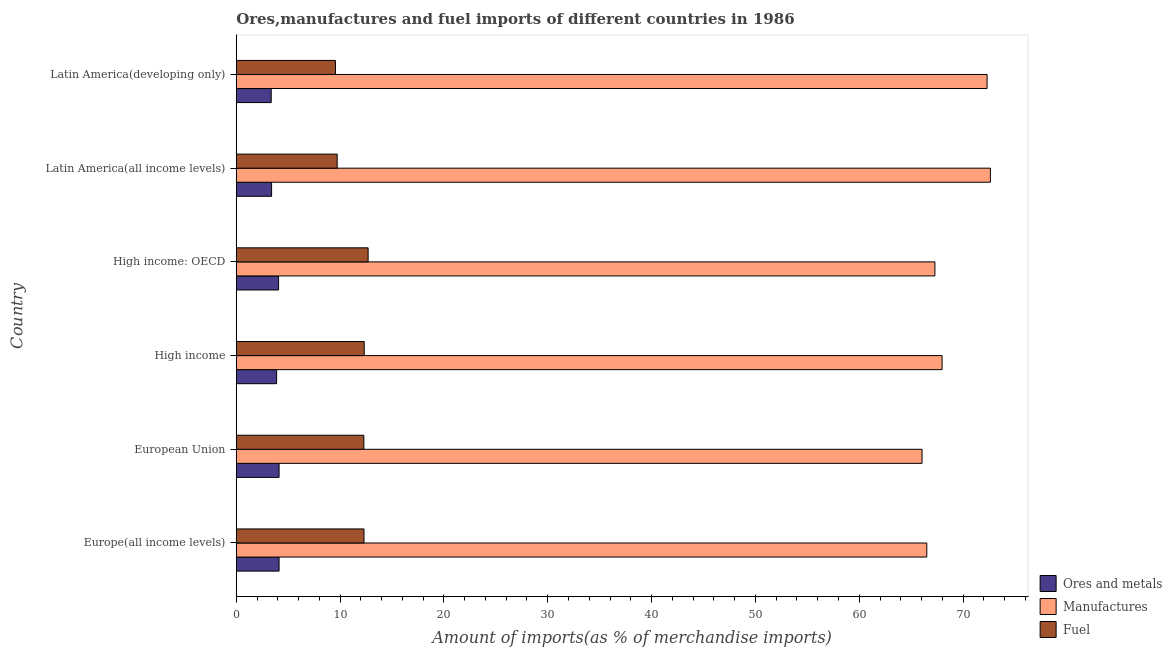How many different coloured bars are there?
Keep it short and to the point. 3. Are the number of bars per tick equal to the number of legend labels?
Ensure brevity in your answer.  Yes. How many bars are there on the 5th tick from the top?
Provide a short and direct response. 3. How many bars are there on the 1st tick from the bottom?
Provide a short and direct response. 3. What is the label of the 1st group of bars from the top?
Make the answer very short. Latin America(developing only). In how many cases, is the number of bars for a given country not equal to the number of legend labels?
Ensure brevity in your answer.  0. What is the percentage of fuel imports in Latin America(all income levels)?
Your answer should be very brief. 9.72. Across all countries, what is the maximum percentage of manufactures imports?
Ensure brevity in your answer.  72.63. Across all countries, what is the minimum percentage of ores and metals imports?
Offer a terse response. 3.37. In which country was the percentage of fuel imports maximum?
Provide a succinct answer. High income: OECD. In which country was the percentage of ores and metals imports minimum?
Provide a short and direct response. Latin America(developing only). What is the total percentage of ores and metals imports in the graph?
Offer a terse response. 22.98. What is the difference between the percentage of ores and metals imports in European Union and that in Latin America(all income levels)?
Ensure brevity in your answer.  0.72. What is the difference between the percentage of ores and metals imports in Europe(all income levels) and the percentage of manufactures imports in European Union?
Offer a terse response. -61.92. What is the average percentage of fuel imports per country?
Give a very brief answer. 11.48. What is the difference between the percentage of fuel imports and percentage of ores and metals imports in High income: OECD?
Keep it short and to the point. 8.62. In how many countries, is the percentage of ores and metals imports greater than 16 %?
Provide a short and direct response. 0. What is the ratio of the percentage of ores and metals imports in High income to that in Latin America(developing only)?
Offer a terse response. 1.16. What is the difference between the highest and the second highest percentage of manufactures imports?
Ensure brevity in your answer.  0.32. What is the difference between the highest and the lowest percentage of ores and metals imports?
Your answer should be very brief. 0.76. In how many countries, is the percentage of fuel imports greater than the average percentage of fuel imports taken over all countries?
Your answer should be very brief. 4. Is the sum of the percentage of ores and metals imports in High income: OECD and Latin America(developing only) greater than the maximum percentage of manufactures imports across all countries?
Your response must be concise. No. What does the 2nd bar from the top in High income: OECD represents?
Provide a succinct answer. Manufactures. What does the 2nd bar from the bottom in High income represents?
Offer a terse response. Manufactures. Are all the bars in the graph horizontal?
Make the answer very short. Yes. How many countries are there in the graph?
Your answer should be compact. 6. What is the difference between two consecutive major ticks on the X-axis?
Keep it short and to the point. 10. Does the graph contain any zero values?
Provide a succinct answer. No. How many legend labels are there?
Your answer should be very brief. 3. What is the title of the graph?
Offer a very short reply. Ores,manufactures and fuel imports of different countries in 1986. Does "Spain" appear as one of the legend labels in the graph?
Your answer should be compact. No. What is the label or title of the X-axis?
Offer a terse response. Amount of imports(as % of merchandise imports). What is the Amount of imports(as % of merchandise imports) in Ores and metals in Europe(all income levels)?
Offer a terse response. 4.12. What is the Amount of imports(as % of merchandise imports) in Manufactures in Europe(all income levels)?
Your response must be concise. 66.51. What is the Amount of imports(as % of merchandise imports) of Fuel in Europe(all income levels)?
Keep it short and to the point. 12.3. What is the Amount of imports(as % of merchandise imports) of Ores and metals in European Union?
Offer a very short reply. 4.12. What is the Amount of imports(as % of merchandise imports) in Manufactures in European Union?
Ensure brevity in your answer.  66.05. What is the Amount of imports(as % of merchandise imports) of Fuel in European Union?
Provide a succinct answer. 12.29. What is the Amount of imports(as % of merchandise imports) in Ores and metals in High income?
Offer a very short reply. 3.89. What is the Amount of imports(as % of merchandise imports) in Manufactures in High income?
Give a very brief answer. 67.98. What is the Amount of imports(as % of merchandise imports) in Fuel in High income?
Keep it short and to the point. 12.32. What is the Amount of imports(as % of merchandise imports) in Ores and metals in High income: OECD?
Give a very brief answer. 4.08. What is the Amount of imports(as % of merchandise imports) in Manufactures in High income: OECD?
Provide a short and direct response. 67.29. What is the Amount of imports(as % of merchandise imports) of Fuel in High income: OECD?
Your answer should be compact. 12.7. What is the Amount of imports(as % of merchandise imports) of Ores and metals in Latin America(all income levels)?
Your response must be concise. 3.4. What is the Amount of imports(as % of merchandise imports) in Manufactures in Latin America(all income levels)?
Keep it short and to the point. 72.63. What is the Amount of imports(as % of merchandise imports) in Fuel in Latin America(all income levels)?
Your answer should be compact. 9.72. What is the Amount of imports(as % of merchandise imports) in Ores and metals in Latin America(developing only)?
Offer a very short reply. 3.37. What is the Amount of imports(as % of merchandise imports) of Manufactures in Latin America(developing only)?
Offer a terse response. 72.31. What is the Amount of imports(as % of merchandise imports) in Fuel in Latin America(developing only)?
Keep it short and to the point. 9.55. Across all countries, what is the maximum Amount of imports(as % of merchandise imports) in Ores and metals?
Your response must be concise. 4.12. Across all countries, what is the maximum Amount of imports(as % of merchandise imports) in Manufactures?
Ensure brevity in your answer.  72.63. Across all countries, what is the maximum Amount of imports(as % of merchandise imports) in Fuel?
Your answer should be very brief. 12.7. Across all countries, what is the minimum Amount of imports(as % of merchandise imports) of Ores and metals?
Your answer should be very brief. 3.37. Across all countries, what is the minimum Amount of imports(as % of merchandise imports) of Manufactures?
Offer a very short reply. 66.05. Across all countries, what is the minimum Amount of imports(as % of merchandise imports) of Fuel?
Keep it short and to the point. 9.55. What is the total Amount of imports(as % of merchandise imports) in Ores and metals in the graph?
Give a very brief answer. 22.98. What is the total Amount of imports(as % of merchandise imports) of Manufactures in the graph?
Offer a terse response. 412.77. What is the total Amount of imports(as % of merchandise imports) of Fuel in the graph?
Your answer should be very brief. 68.89. What is the difference between the Amount of imports(as % of merchandise imports) in Manufactures in Europe(all income levels) and that in European Union?
Offer a very short reply. 0.46. What is the difference between the Amount of imports(as % of merchandise imports) in Fuel in Europe(all income levels) and that in European Union?
Make the answer very short. 0.01. What is the difference between the Amount of imports(as % of merchandise imports) of Ores and metals in Europe(all income levels) and that in High income?
Offer a very short reply. 0.24. What is the difference between the Amount of imports(as % of merchandise imports) in Manufactures in Europe(all income levels) and that in High income?
Keep it short and to the point. -1.47. What is the difference between the Amount of imports(as % of merchandise imports) in Fuel in Europe(all income levels) and that in High income?
Offer a very short reply. -0.02. What is the difference between the Amount of imports(as % of merchandise imports) in Ores and metals in Europe(all income levels) and that in High income: OECD?
Your response must be concise. 0.05. What is the difference between the Amount of imports(as % of merchandise imports) of Manufactures in Europe(all income levels) and that in High income: OECD?
Keep it short and to the point. -0.78. What is the difference between the Amount of imports(as % of merchandise imports) of Fuel in Europe(all income levels) and that in High income: OECD?
Provide a succinct answer. -0.4. What is the difference between the Amount of imports(as % of merchandise imports) of Ores and metals in Europe(all income levels) and that in Latin America(all income levels)?
Offer a very short reply. 0.72. What is the difference between the Amount of imports(as % of merchandise imports) in Manufactures in Europe(all income levels) and that in Latin America(all income levels)?
Your response must be concise. -6.13. What is the difference between the Amount of imports(as % of merchandise imports) of Fuel in Europe(all income levels) and that in Latin America(all income levels)?
Your answer should be very brief. 2.59. What is the difference between the Amount of imports(as % of merchandise imports) of Ores and metals in Europe(all income levels) and that in Latin America(developing only)?
Offer a very short reply. 0.76. What is the difference between the Amount of imports(as % of merchandise imports) of Manufactures in Europe(all income levels) and that in Latin America(developing only)?
Offer a very short reply. -5.81. What is the difference between the Amount of imports(as % of merchandise imports) in Fuel in Europe(all income levels) and that in Latin America(developing only)?
Your response must be concise. 2.75. What is the difference between the Amount of imports(as % of merchandise imports) in Ores and metals in European Union and that in High income?
Your response must be concise. 0.24. What is the difference between the Amount of imports(as % of merchandise imports) in Manufactures in European Union and that in High income?
Provide a short and direct response. -1.93. What is the difference between the Amount of imports(as % of merchandise imports) of Fuel in European Union and that in High income?
Your answer should be compact. -0.03. What is the difference between the Amount of imports(as % of merchandise imports) in Ores and metals in European Union and that in High income: OECD?
Give a very brief answer. 0.05. What is the difference between the Amount of imports(as % of merchandise imports) in Manufactures in European Union and that in High income: OECD?
Make the answer very short. -1.24. What is the difference between the Amount of imports(as % of merchandise imports) of Fuel in European Union and that in High income: OECD?
Offer a terse response. -0.41. What is the difference between the Amount of imports(as % of merchandise imports) in Ores and metals in European Union and that in Latin America(all income levels)?
Offer a very short reply. 0.72. What is the difference between the Amount of imports(as % of merchandise imports) in Manufactures in European Union and that in Latin America(all income levels)?
Provide a succinct answer. -6.58. What is the difference between the Amount of imports(as % of merchandise imports) of Fuel in European Union and that in Latin America(all income levels)?
Make the answer very short. 2.57. What is the difference between the Amount of imports(as % of merchandise imports) of Ores and metals in European Union and that in Latin America(developing only)?
Your answer should be compact. 0.76. What is the difference between the Amount of imports(as % of merchandise imports) of Manufactures in European Union and that in Latin America(developing only)?
Offer a very short reply. -6.26. What is the difference between the Amount of imports(as % of merchandise imports) in Fuel in European Union and that in Latin America(developing only)?
Offer a terse response. 2.74. What is the difference between the Amount of imports(as % of merchandise imports) of Ores and metals in High income and that in High income: OECD?
Offer a terse response. -0.19. What is the difference between the Amount of imports(as % of merchandise imports) in Manufactures in High income and that in High income: OECD?
Make the answer very short. 0.69. What is the difference between the Amount of imports(as % of merchandise imports) in Fuel in High income and that in High income: OECD?
Your answer should be compact. -0.38. What is the difference between the Amount of imports(as % of merchandise imports) of Ores and metals in High income and that in Latin America(all income levels)?
Make the answer very short. 0.48. What is the difference between the Amount of imports(as % of merchandise imports) in Manufactures in High income and that in Latin America(all income levels)?
Provide a short and direct response. -4.65. What is the difference between the Amount of imports(as % of merchandise imports) of Fuel in High income and that in Latin America(all income levels)?
Give a very brief answer. 2.61. What is the difference between the Amount of imports(as % of merchandise imports) in Ores and metals in High income and that in Latin America(developing only)?
Your answer should be compact. 0.52. What is the difference between the Amount of imports(as % of merchandise imports) of Manufactures in High income and that in Latin America(developing only)?
Your answer should be compact. -4.33. What is the difference between the Amount of imports(as % of merchandise imports) of Fuel in High income and that in Latin America(developing only)?
Offer a terse response. 2.77. What is the difference between the Amount of imports(as % of merchandise imports) in Ores and metals in High income: OECD and that in Latin America(all income levels)?
Offer a terse response. 0.67. What is the difference between the Amount of imports(as % of merchandise imports) in Manufactures in High income: OECD and that in Latin America(all income levels)?
Provide a short and direct response. -5.34. What is the difference between the Amount of imports(as % of merchandise imports) of Fuel in High income: OECD and that in Latin America(all income levels)?
Your answer should be compact. 2.98. What is the difference between the Amount of imports(as % of merchandise imports) of Ores and metals in High income: OECD and that in Latin America(developing only)?
Make the answer very short. 0.71. What is the difference between the Amount of imports(as % of merchandise imports) in Manufactures in High income: OECD and that in Latin America(developing only)?
Your answer should be very brief. -5.02. What is the difference between the Amount of imports(as % of merchandise imports) of Fuel in High income: OECD and that in Latin America(developing only)?
Provide a short and direct response. 3.15. What is the difference between the Amount of imports(as % of merchandise imports) of Ores and metals in Latin America(all income levels) and that in Latin America(developing only)?
Ensure brevity in your answer.  0.04. What is the difference between the Amount of imports(as % of merchandise imports) in Manufactures in Latin America(all income levels) and that in Latin America(developing only)?
Your answer should be compact. 0.32. What is the difference between the Amount of imports(as % of merchandise imports) in Fuel in Latin America(all income levels) and that in Latin America(developing only)?
Your response must be concise. 0.16. What is the difference between the Amount of imports(as % of merchandise imports) of Ores and metals in Europe(all income levels) and the Amount of imports(as % of merchandise imports) of Manufactures in European Union?
Keep it short and to the point. -61.92. What is the difference between the Amount of imports(as % of merchandise imports) in Ores and metals in Europe(all income levels) and the Amount of imports(as % of merchandise imports) in Fuel in European Union?
Your response must be concise. -8.16. What is the difference between the Amount of imports(as % of merchandise imports) in Manufactures in Europe(all income levels) and the Amount of imports(as % of merchandise imports) in Fuel in European Union?
Your answer should be compact. 54.22. What is the difference between the Amount of imports(as % of merchandise imports) in Ores and metals in Europe(all income levels) and the Amount of imports(as % of merchandise imports) in Manufactures in High income?
Make the answer very short. -63.85. What is the difference between the Amount of imports(as % of merchandise imports) in Ores and metals in Europe(all income levels) and the Amount of imports(as % of merchandise imports) in Fuel in High income?
Give a very brief answer. -8.2. What is the difference between the Amount of imports(as % of merchandise imports) of Manufactures in Europe(all income levels) and the Amount of imports(as % of merchandise imports) of Fuel in High income?
Ensure brevity in your answer.  54.18. What is the difference between the Amount of imports(as % of merchandise imports) of Ores and metals in Europe(all income levels) and the Amount of imports(as % of merchandise imports) of Manufactures in High income: OECD?
Keep it short and to the point. -63.16. What is the difference between the Amount of imports(as % of merchandise imports) in Ores and metals in Europe(all income levels) and the Amount of imports(as % of merchandise imports) in Fuel in High income: OECD?
Ensure brevity in your answer.  -8.58. What is the difference between the Amount of imports(as % of merchandise imports) in Manufactures in Europe(all income levels) and the Amount of imports(as % of merchandise imports) in Fuel in High income: OECD?
Ensure brevity in your answer.  53.81. What is the difference between the Amount of imports(as % of merchandise imports) of Ores and metals in Europe(all income levels) and the Amount of imports(as % of merchandise imports) of Manufactures in Latin America(all income levels)?
Your answer should be compact. -68.51. What is the difference between the Amount of imports(as % of merchandise imports) of Ores and metals in Europe(all income levels) and the Amount of imports(as % of merchandise imports) of Fuel in Latin America(all income levels)?
Provide a succinct answer. -5.59. What is the difference between the Amount of imports(as % of merchandise imports) in Manufactures in Europe(all income levels) and the Amount of imports(as % of merchandise imports) in Fuel in Latin America(all income levels)?
Ensure brevity in your answer.  56.79. What is the difference between the Amount of imports(as % of merchandise imports) of Ores and metals in Europe(all income levels) and the Amount of imports(as % of merchandise imports) of Manufactures in Latin America(developing only)?
Provide a succinct answer. -68.19. What is the difference between the Amount of imports(as % of merchandise imports) in Ores and metals in Europe(all income levels) and the Amount of imports(as % of merchandise imports) in Fuel in Latin America(developing only)?
Make the answer very short. -5.43. What is the difference between the Amount of imports(as % of merchandise imports) of Manufactures in Europe(all income levels) and the Amount of imports(as % of merchandise imports) of Fuel in Latin America(developing only)?
Make the answer very short. 56.95. What is the difference between the Amount of imports(as % of merchandise imports) in Ores and metals in European Union and the Amount of imports(as % of merchandise imports) in Manufactures in High income?
Give a very brief answer. -63.86. What is the difference between the Amount of imports(as % of merchandise imports) in Ores and metals in European Union and the Amount of imports(as % of merchandise imports) in Fuel in High income?
Your answer should be compact. -8.2. What is the difference between the Amount of imports(as % of merchandise imports) in Manufactures in European Union and the Amount of imports(as % of merchandise imports) in Fuel in High income?
Your answer should be compact. 53.73. What is the difference between the Amount of imports(as % of merchandise imports) in Ores and metals in European Union and the Amount of imports(as % of merchandise imports) in Manufactures in High income: OECD?
Your response must be concise. -63.16. What is the difference between the Amount of imports(as % of merchandise imports) in Ores and metals in European Union and the Amount of imports(as % of merchandise imports) in Fuel in High income: OECD?
Your answer should be compact. -8.58. What is the difference between the Amount of imports(as % of merchandise imports) of Manufactures in European Union and the Amount of imports(as % of merchandise imports) of Fuel in High income: OECD?
Offer a terse response. 53.35. What is the difference between the Amount of imports(as % of merchandise imports) in Ores and metals in European Union and the Amount of imports(as % of merchandise imports) in Manufactures in Latin America(all income levels)?
Give a very brief answer. -68.51. What is the difference between the Amount of imports(as % of merchandise imports) in Ores and metals in European Union and the Amount of imports(as % of merchandise imports) in Fuel in Latin America(all income levels)?
Keep it short and to the point. -5.59. What is the difference between the Amount of imports(as % of merchandise imports) in Manufactures in European Union and the Amount of imports(as % of merchandise imports) in Fuel in Latin America(all income levels)?
Ensure brevity in your answer.  56.33. What is the difference between the Amount of imports(as % of merchandise imports) of Ores and metals in European Union and the Amount of imports(as % of merchandise imports) of Manufactures in Latin America(developing only)?
Ensure brevity in your answer.  -68.19. What is the difference between the Amount of imports(as % of merchandise imports) in Ores and metals in European Union and the Amount of imports(as % of merchandise imports) in Fuel in Latin America(developing only)?
Keep it short and to the point. -5.43. What is the difference between the Amount of imports(as % of merchandise imports) in Manufactures in European Union and the Amount of imports(as % of merchandise imports) in Fuel in Latin America(developing only)?
Your answer should be compact. 56.5. What is the difference between the Amount of imports(as % of merchandise imports) in Ores and metals in High income and the Amount of imports(as % of merchandise imports) in Manufactures in High income: OECD?
Ensure brevity in your answer.  -63.4. What is the difference between the Amount of imports(as % of merchandise imports) in Ores and metals in High income and the Amount of imports(as % of merchandise imports) in Fuel in High income: OECD?
Provide a short and direct response. -8.81. What is the difference between the Amount of imports(as % of merchandise imports) of Manufactures in High income and the Amount of imports(as % of merchandise imports) of Fuel in High income: OECD?
Make the answer very short. 55.28. What is the difference between the Amount of imports(as % of merchandise imports) of Ores and metals in High income and the Amount of imports(as % of merchandise imports) of Manufactures in Latin America(all income levels)?
Your response must be concise. -68.74. What is the difference between the Amount of imports(as % of merchandise imports) of Ores and metals in High income and the Amount of imports(as % of merchandise imports) of Fuel in Latin America(all income levels)?
Your response must be concise. -5.83. What is the difference between the Amount of imports(as % of merchandise imports) of Manufactures in High income and the Amount of imports(as % of merchandise imports) of Fuel in Latin America(all income levels)?
Provide a short and direct response. 58.26. What is the difference between the Amount of imports(as % of merchandise imports) in Ores and metals in High income and the Amount of imports(as % of merchandise imports) in Manufactures in Latin America(developing only)?
Keep it short and to the point. -68.42. What is the difference between the Amount of imports(as % of merchandise imports) in Ores and metals in High income and the Amount of imports(as % of merchandise imports) in Fuel in Latin America(developing only)?
Provide a succinct answer. -5.66. What is the difference between the Amount of imports(as % of merchandise imports) in Manufactures in High income and the Amount of imports(as % of merchandise imports) in Fuel in Latin America(developing only)?
Offer a terse response. 58.43. What is the difference between the Amount of imports(as % of merchandise imports) of Ores and metals in High income: OECD and the Amount of imports(as % of merchandise imports) of Manufactures in Latin America(all income levels)?
Provide a succinct answer. -68.56. What is the difference between the Amount of imports(as % of merchandise imports) in Ores and metals in High income: OECD and the Amount of imports(as % of merchandise imports) in Fuel in Latin America(all income levels)?
Give a very brief answer. -5.64. What is the difference between the Amount of imports(as % of merchandise imports) in Manufactures in High income: OECD and the Amount of imports(as % of merchandise imports) in Fuel in Latin America(all income levels)?
Your response must be concise. 57.57. What is the difference between the Amount of imports(as % of merchandise imports) in Ores and metals in High income: OECD and the Amount of imports(as % of merchandise imports) in Manufactures in Latin America(developing only)?
Your answer should be compact. -68.24. What is the difference between the Amount of imports(as % of merchandise imports) in Ores and metals in High income: OECD and the Amount of imports(as % of merchandise imports) in Fuel in Latin America(developing only)?
Your answer should be very brief. -5.48. What is the difference between the Amount of imports(as % of merchandise imports) in Manufactures in High income: OECD and the Amount of imports(as % of merchandise imports) in Fuel in Latin America(developing only)?
Offer a terse response. 57.74. What is the difference between the Amount of imports(as % of merchandise imports) of Ores and metals in Latin America(all income levels) and the Amount of imports(as % of merchandise imports) of Manufactures in Latin America(developing only)?
Provide a short and direct response. -68.91. What is the difference between the Amount of imports(as % of merchandise imports) in Ores and metals in Latin America(all income levels) and the Amount of imports(as % of merchandise imports) in Fuel in Latin America(developing only)?
Your response must be concise. -6.15. What is the difference between the Amount of imports(as % of merchandise imports) in Manufactures in Latin America(all income levels) and the Amount of imports(as % of merchandise imports) in Fuel in Latin America(developing only)?
Provide a short and direct response. 63.08. What is the average Amount of imports(as % of merchandise imports) of Ores and metals per country?
Your answer should be compact. 3.83. What is the average Amount of imports(as % of merchandise imports) in Manufactures per country?
Ensure brevity in your answer.  68.79. What is the average Amount of imports(as % of merchandise imports) of Fuel per country?
Provide a short and direct response. 11.48. What is the difference between the Amount of imports(as % of merchandise imports) in Ores and metals and Amount of imports(as % of merchandise imports) in Manufactures in Europe(all income levels)?
Provide a succinct answer. -62.38. What is the difference between the Amount of imports(as % of merchandise imports) of Ores and metals and Amount of imports(as % of merchandise imports) of Fuel in Europe(all income levels)?
Offer a terse response. -8.18. What is the difference between the Amount of imports(as % of merchandise imports) of Manufactures and Amount of imports(as % of merchandise imports) of Fuel in Europe(all income levels)?
Make the answer very short. 54.2. What is the difference between the Amount of imports(as % of merchandise imports) of Ores and metals and Amount of imports(as % of merchandise imports) of Manufactures in European Union?
Give a very brief answer. -61.92. What is the difference between the Amount of imports(as % of merchandise imports) in Ores and metals and Amount of imports(as % of merchandise imports) in Fuel in European Union?
Ensure brevity in your answer.  -8.16. What is the difference between the Amount of imports(as % of merchandise imports) in Manufactures and Amount of imports(as % of merchandise imports) in Fuel in European Union?
Offer a very short reply. 53.76. What is the difference between the Amount of imports(as % of merchandise imports) in Ores and metals and Amount of imports(as % of merchandise imports) in Manufactures in High income?
Keep it short and to the point. -64.09. What is the difference between the Amount of imports(as % of merchandise imports) in Ores and metals and Amount of imports(as % of merchandise imports) in Fuel in High income?
Make the answer very short. -8.44. What is the difference between the Amount of imports(as % of merchandise imports) of Manufactures and Amount of imports(as % of merchandise imports) of Fuel in High income?
Your answer should be compact. 55.66. What is the difference between the Amount of imports(as % of merchandise imports) of Ores and metals and Amount of imports(as % of merchandise imports) of Manufactures in High income: OECD?
Make the answer very short. -63.21. What is the difference between the Amount of imports(as % of merchandise imports) in Ores and metals and Amount of imports(as % of merchandise imports) in Fuel in High income: OECD?
Make the answer very short. -8.62. What is the difference between the Amount of imports(as % of merchandise imports) in Manufactures and Amount of imports(as % of merchandise imports) in Fuel in High income: OECD?
Offer a very short reply. 54.59. What is the difference between the Amount of imports(as % of merchandise imports) of Ores and metals and Amount of imports(as % of merchandise imports) of Manufactures in Latin America(all income levels)?
Your response must be concise. -69.23. What is the difference between the Amount of imports(as % of merchandise imports) of Ores and metals and Amount of imports(as % of merchandise imports) of Fuel in Latin America(all income levels)?
Your answer should be compact. -6.31. What is the difference between the Amount of imports(as % of merchandise imports) in Manufactures and Amount of imports(as % of merchandise imports) in Fuel in Latin America(all income levels)?
Provide a succinct answer. 62.92. What is the difference between the Amount of imports(as % of merchandise imports) of Ores and metals and Amount of imports(as % of merchandise imports) of Manufactures in Latin America(developing only)?
Make the answer very short. -68.95. What is the difference between the Amount of imports(as % of merchandise imports) in Ores and metals and Amount of imports(as % of merchandise imports) in Fuel in Latin America(developing only)?
Provide a short and direct response. -6.19. What is the difference between the Amount of imports(as % of merchandise imports) of Manufactures and Amount of imports(as % of merchandise imports) of Fuel in Latin America(developing only)?
Provide a short and direct response. 62.76. What is the ratio of the Amount of imports(as % of merchandise imports) in Ores and metals in Europe(all income levels) to that in European Union?
Provide a succinct answer. 1. What is the ratio of the Amount of imports(as % of merchandise imports) in Manufactures in Europe(all income levels) to that in European Union?
Provide a short and direct response. 1.01. What is the ratio of the Amount of imports(as % of merchandise imports) in Fuel in Europe(all income levels) to that in European Union?
Offer a terse response. 1. What is the ratio of the Amount of imports(as % of merchandise imports) of Ores and metals in Europe(all income levels) to that in High income?
Make the answer very short. 1.06. What is the ratio of the Amount of imports(as % of merchandise imports) of Manufactures in Europe(all income levels) to that in High income?
Give a very brief answer. 0.98. What is the ratio of the Amount of imports(as % of merchandise imports) of Fuel in Europe(all income levels) to that in High income?
Your answer should be compact. 1. What is the ratio of the Amount of imports(as % of merchandise imports) of Ores and metals in Europe(all income levels) to that in High income: OECD?
Offer a very short reply. 1.01. What is the ratio of the Amount of imports(as % of merchandise imports) in Manufactures in Europe(all income levels) to that in High income: OECD?
Your answer should be compact. 0.99. What is the ratio of the Amount of imports(as % of merchandise imports) in Fuel in Europe(all income levels) to that in High income: OECD?
Keep it short and to the point. 0.97. What is the ratio of the Amount of imports(as % of merchandise imports) in Ores and metals in Europe(all income levels) to that in Latin America(all income levels)?
Provide a succinct answer. 1.21. What is the ratio of the Amount of imports(as % of merchandise imports) of Manufactures in Europe(all income levels) to that in Latin America(all income levels)?
Provide a succinct answer. 0.92. What is the ratio of the Amount of imports(as % of merchandise imports) in Fuel in Europe(all income levels) to that in Latin America(all income levels)?
Offer a terse response. 1.27. What is the ratio of the Amount of imports(as % of merchandise imports) of Ores and metals in Europe(all income levels) to that in Latin America(developing only)?
Provide a succinct answer. 1.23. What is the ratio of the Amount of imports(as % of merchandise imports) in Manufactures in Europe(all income levels) to that in Latin America(developing only)?
Your response must be concise. 0.92. What is the ratio of the Amount of imports(as % of merchandise imports) of Fuel in Europe(all income levels) to that in Latin America(developing only)?
Offer a terse response. 1.29. What is the ratio of the Amount of imports(as % of merchandise imports) of Ores and metals in European Union to that in High income?
Ensure brevity in your answer.  1.06. What is the ratio of the Amount of imports(as % of merchandise imports) of Manufactures in European Union to that in High income?
Offer a terse response. 0.97. What is the ratio of the Amount of imports(as % of merchandise imports) in Ores and metals in European Union to that in High income: OECD?
Provide a succinct answer. 1.01. What is the ratio of the Amount of imports(as % of merchandise imports) of Manufactures in European Union to that in High income: OECD?
Make the answer very short. 0.98. What is the ratio of the Amount of imports(as % of merchandise imports) in Fuel in European Union to that in High income: OECD?
Offer a terse response. 0.97. What is the ratio of the Amount of imports(as % of merchandise imports) of Ores and metals in European Union to that in Latin America(all income levels)?
Your answer should be compact. 1.21. What is the ratio of the Amount of imports(as % of merchandise imports) in Manufactures in European Union to that in Latin America(all income levels)?
Your response must be concise. 0.91. What is the ratio of the Amount of imports(as % of merchandise imports) of Fuel in European Union to that in Latin America(all income levels)?
Keep it short and to the point. 1.26. What is the ratio of the Amount of imports(as % of merchandise imports) of Ores and metals in European Union to that in Latin America(developing only)?
Your answer should be very brief. 1.23. What is the ratio of the Amount of imports(as % of merchandise imports) of Manufactures in European Union to that in Latin America(developing only)?
Provide a succinct answer. 0.91. What is the ratio of the Amount of imports(as % of merchandise imports) of Fuel in European Union to that in Latin America(developing only)?
Keep it short and to the point. 1.29. What is the ratio of the Amount of imports(as % of merchandise imports) in Ores and metals in High income to that in High income: OECD?
Ensure brevity in your answer.  0.95. What is the ratio of the Amount of imports(as % of merchandise imports) of Manufactures in High income to that in High income: OECD?
Make the answer very short. 1.01. What is the ratio of the Amount of imports(as % of merchandise imports) in Fuel in High income to that in High income: OECD?
Your response must be concise. 0.97. What is the ratio of the Amount of imports(as % of merchandise imports) in Ores and metals in High income to that in Latin America(all income levels)?
Your response must be concise. 1.14. What is the ratio of the Amount of imports(as % of merchandise imports) in Manufactures in High income to that in Latin America(all income levels)?
Offer a terse response. 0.94. What is the ratio of the Amount of imports(as % of merchandise imports) in Fuel in High income to that in Latin America(all income levels)?
Your response must be concise. 1.27. What is the ratio of the Amount of imports(as % of merchandise imports) in Ores and metals in High income to that in Latin America(developing only)?
Your answer should be very brief. 1.16. What is the ratio of the Amount of imports(as % of merchandise imports) of Manufactures in High income to that in Latin America(developing only)?
Your answer should be very brief. 0.94. What is the ratio of the Amount of imports(as % of merchandise imports) in Fuel in High income to that in Latin America(developing only)?
Make the answer very short. 1.29. What is the ratio of the Amount of imports(as % of merchandise imports) of Ores and metals in High income: OECD to that in Latin America(all income levels)?
Give a very brief answer. 1.2. What is the ratio of the Amount of imports(as % of merchandise imports) of Manufactures in High income: OECD to that in Latin America(all income levels)?
Your response must be concise. 0.93. What is the ratio of the Amount of imports(as % of merchandise imports) of Fuel in High income: OECD to that in Latin America(all income levels)?
Make the answer very short. 1.31. What is the ratio of the Amount of imports(as % of merchandise imports) of Ores and metals in High income: OECD to that in Latin America(developing only)?
Your answer should be compact. 1.21. What is the ratio of the Amount of imports(as % of merchandise imports) of Manufactures in High income: OECD to that in Latin America(developing only)?
Your response must be concise. 0.93. What is the ratio of the Amount of imports(as % of merchandise imports) in Fuel in High income: OECD to that in Latin America(developing only)?
Offer a terse response. 1.33. What is the ratio of the Amount of imports(as % of merchandise imports) of Ores and metals in Latin America(all income levels) to that in Latin America(developing only)?
Provide a succinct answer. 1.01. What is the ratio of the Amount of imports(as % of merchandise imports) in Manufactures in Latin America(all income levels) to that in Latin America(developing only)?
Ensure brevity in your answer.  1. What is the ratio of the Amount of imports(as % of merchandise imports) in Fuel in Latin America(all income levels) to that in Latin America(developing only)?
Your response must be concise. 1.02. What is the difference between the highest and the second highest Amount of imports(as % of merchandise imports) of Manufactures?
Offer a very short reply. 0.32. What is the difference between the highest and the second highest Amount of imports(as % of merchandise imports) of Fuel?
Your response must be concise. 0.38. What is the difference between the highest and the lowest Amount of imports(as % of merchandise imports) in Ores and metals?
Ensure brevity in your answer.  0.76. What is the difference between the highest and the lowest Amount of imports(as % of merchandise imports) in Manufactures?
Make the answer very short. 6.58. What is the difference between the highest and the lowest Amount of imports(as % of merchandise imports) of Fuel?
Provide a short and direct response. 3.15. 